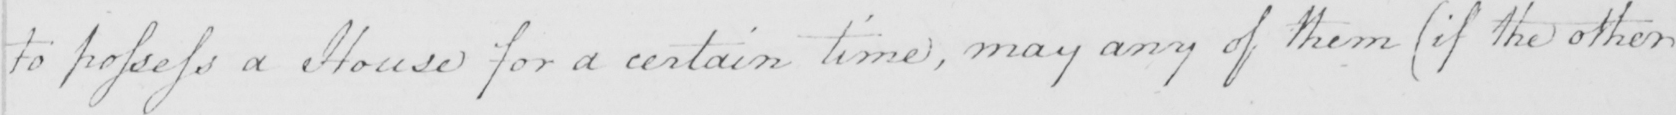Transcribe the text shown in this historical manuscript line. to possess a House for a certain time , may any of them  ( if the other 